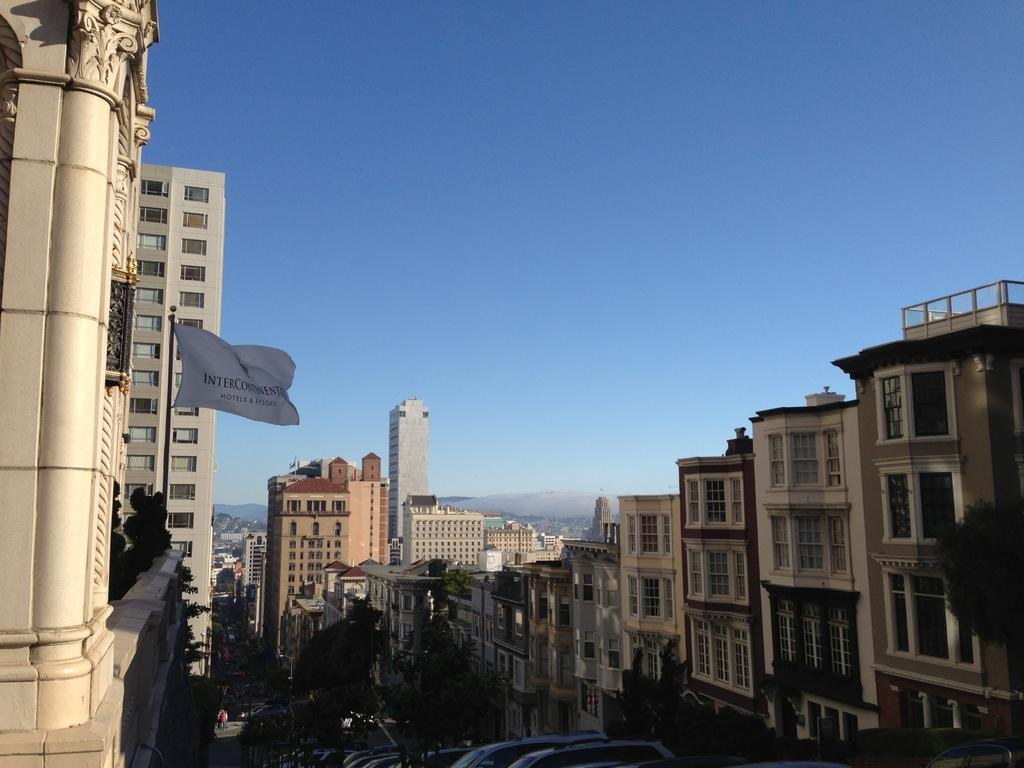What is the main subject in the center of the image? There are buildings in the center of the image. Can you describe the building on the left side of the image? There is a building with a flag on the left side of the image. What is visible at the top of the image? The sky is visible at the top of the image. Where are the bears nesting in the image? There are no bears or nests present in the image. What type of alarm can be heard in the image? There is no audible alarm in the image, as it is a static visual representation. 